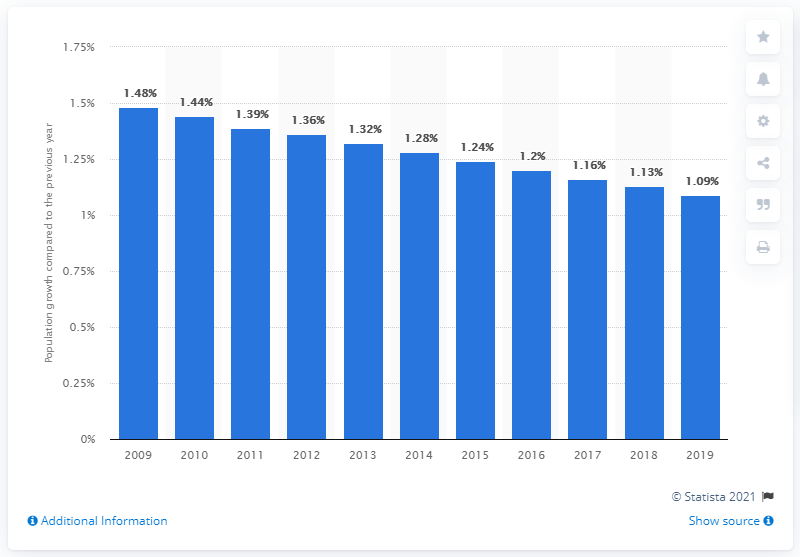Specify some key components in this picture. The population of Mexico grew by 1.09% in 2019. 